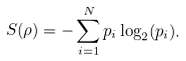Convert formula to latex. <formula><loc_0><loc_0><loc_500><loc_500>S ( \rho ) = - \sum _ { i = 1 } ^ { N } p _ { i } \log _ { 2 } ( p _ { i } ) .</formula> 